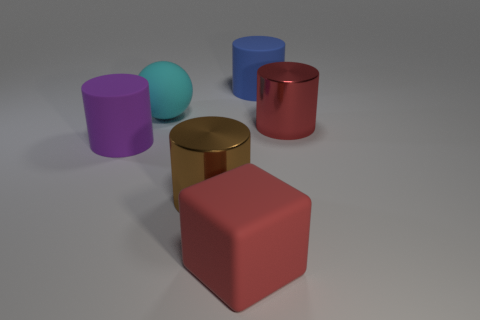What number of metallic objects are either cyan spheres or small yellow cylinders?
Your answer should be compact. 0. What shape is the red thing in front of the shiny cylinder to the right of the brown metallic cylinder?
Make the answer very short. Cube. Is the number of red objects that are behind the block less than the number of large red metal things?
Offer a terse response. No. What shape is the big blue rubber object?
Your response must be concise. Cylinder. What is the color of the matte ball that is the same size as the brown metal cylinder?
Provide a succinct answer. Cyan. Are there any metal objects of the same color as the cube?
Give a very brief answer. Yes. Is the number of large shiny objects that are in front of the big brown metal cylinder less than the number of cyan rubber things on the left side of the rubber cube?
Provide a succinct answer. Yes. What is the material of the large cylinder that is right of the brown shiny object and left of the big red shiny thing?
Your answer should be very brief. Rubber. Is the shape of the large brown object the same as the large red thing that is to the right of the blue matte cylinder?
Provide a succinct answer. Yes. How many other objects are there of the same size as the blue cylinder?
Provide a short and direct response. 5. 